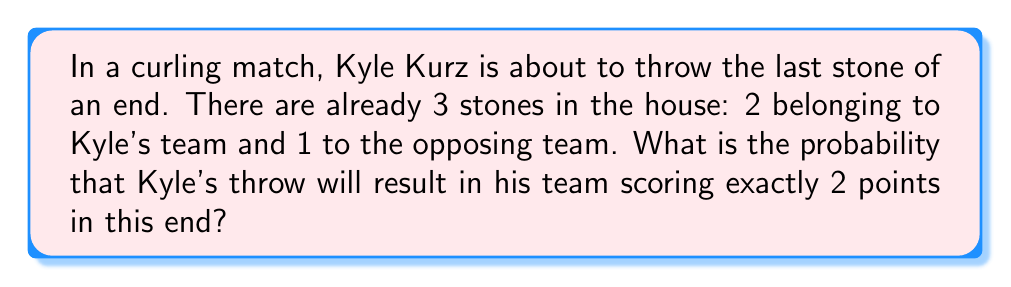Show me your answer to this math problem. Let's approach this step-by-step:

1) In curling, points are scored based on the stones closest to the center of the house after all 16 stones have been thrown.

2) For Kyle's team to score exactly 2 points, their two stones already in the house must remain the two closest to the center after Kyle's throw.

3) There are several possible outcomes for Kyle's throw:
   a) It could knock out the opponent's stone without displacing his team's stones.
   b) It could come to rest closer to the center than the opponent's stone but farther than his team's stones.
   c) It could miss the house entirely or have no effect on the scoring.
   d) It could accidentally displace his own team's stones or improve the position of the opponent's stone.

4) Let's assign probabilities to these outcomes:
   - Probability of outcome a or b (favorable outcomes): $p = 0.6$
   - Probability of outcome c (neutral outcome): $q = 0.3$
   - Probability of outcome d (unfavorable outcome): $r = 0.1$

5) The probability of scoring exactly 2 points is the sum of the probabilities of outcomes a, b, and c:

   $$P(\text{scoring 2 points}) = p + q = 0.6 + 0.3 = 0.9$$

Therefore, the probability of Kyle's team scoring exactly 2 points in this end is 0.9 or 90%.
Answer: $0.9$ 